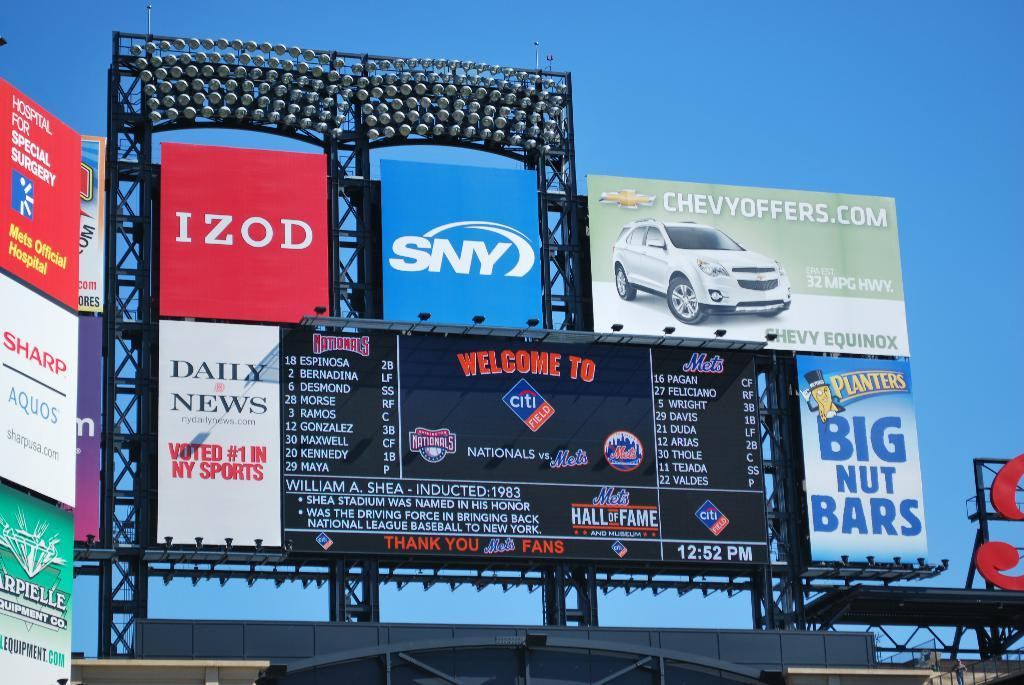<image>
Share a concise interpretation of the image provided. A bright red IZOD ad sits next to a SNY ad that is blue. 